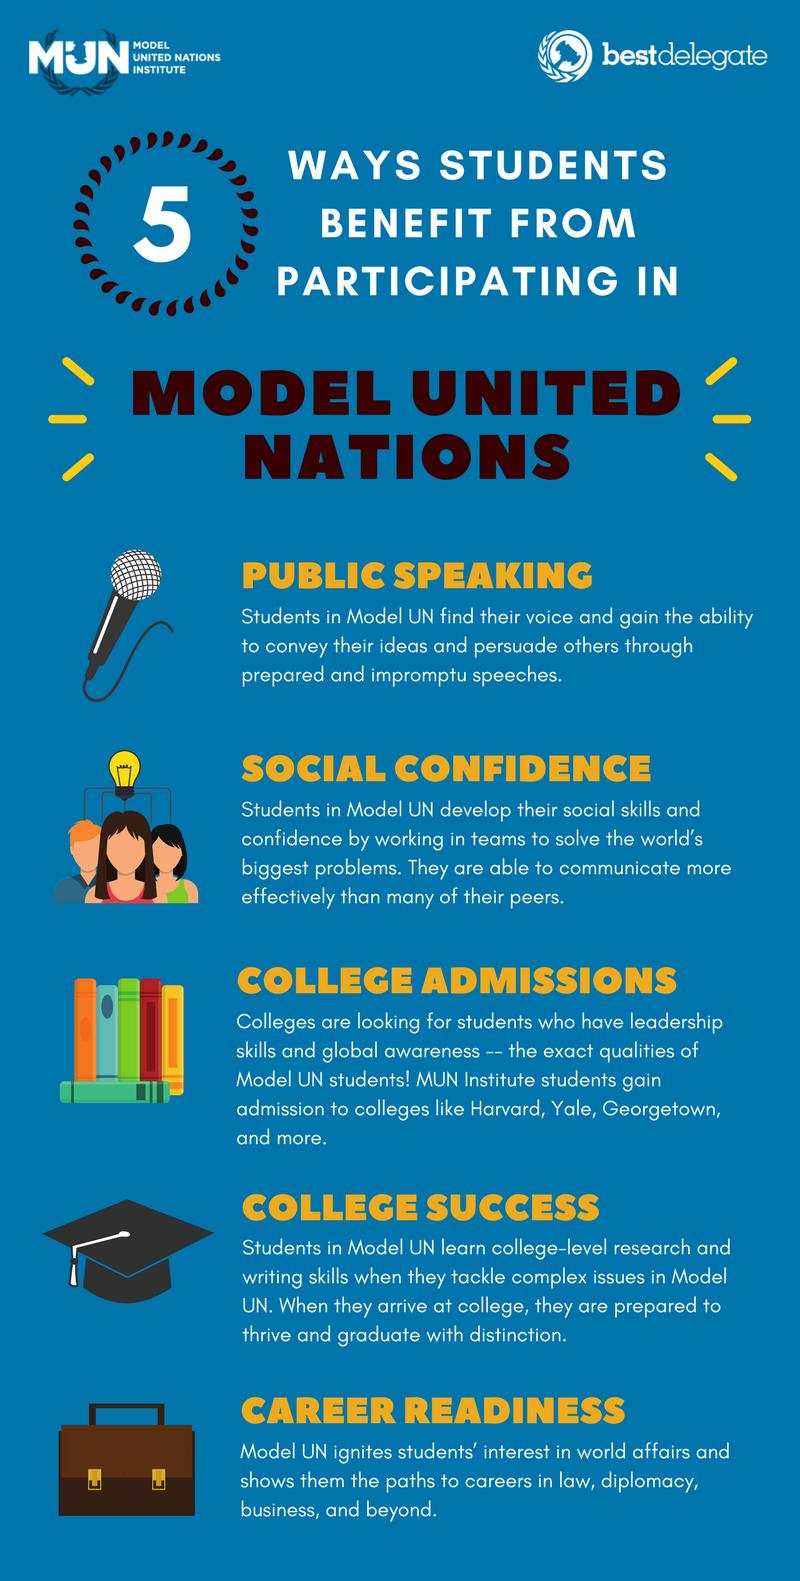Draw attention to some important aspects in this diagram. The microphone image highlights the benefit of public speaking. The graduation cap serves as a symbol of success in college. The color of the bag is brown, not black. Participating in Model United Nations offers numerous benefits beyond college admissions and academic success, including improved public speaking skills, enhanced social confidence, and increased career readiness. 